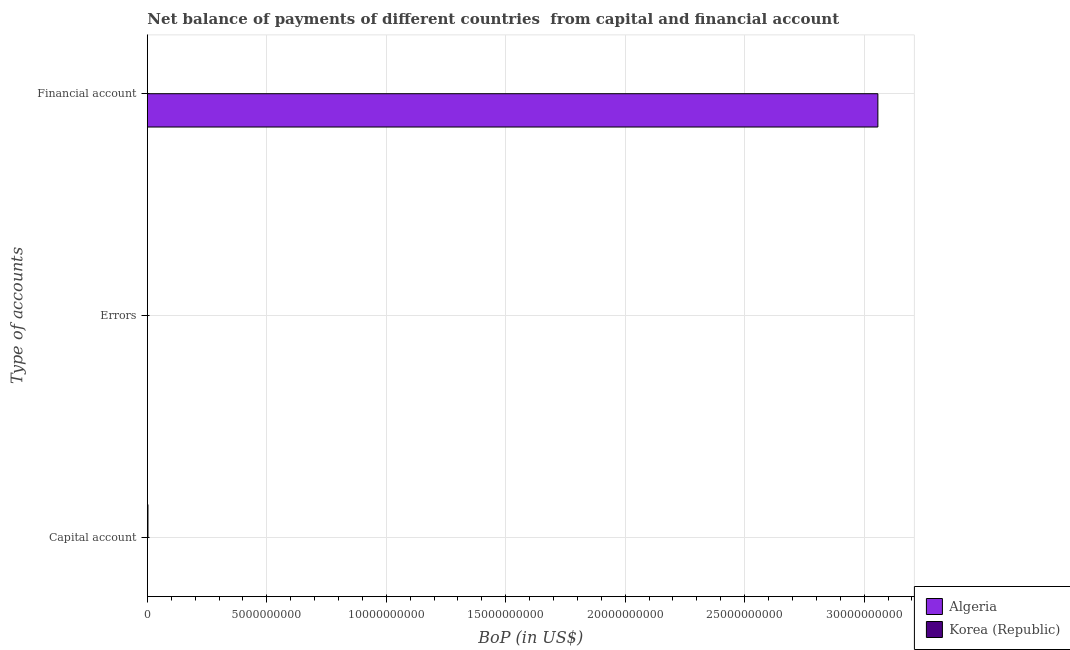Are the number of bars on each tick of the Y-axis equal?
Your answer should be compact. No. How many bars are there on the 3rd tick from the bottom?
Your response must be concise. 1. What is the label of the 1st group of bars from the top?
Give a very brief answer. Financial account. What is the amount of net capital account in Korea (Republic)?
Offer a terse response. 2.64e+07. Across all countries, what is the maximum amount of net capital account?
Keep it short and to the point. 2.64e+07. Across all countries, what is the minimum amount of errors?
Your response must be concise. 0. In which country was the amount of financial account maximum?
Provide a short and direct response. Algeria. What is the total amount of net capital account in the graph?
Ensure brevity in your answer.  2.64e+07. What is the difference between the amount of errors in Algeria and the amount of net capital account in Korea (Republic)?
Your response must be concise. -2.64e+07. What is the average amount of financial account per country?
Offer a very short reply. 1.53e+1. In how many countries, is the amount of net capital account greater than 29000000000 US$?
Give a very brief answer. 0. What is the difference between the highest and the lowest amount of financial account?
Keep it short and to the point. 3.06e+1. In how many countries, is the amount of net capital account greater than the average amount of net capital account taken over all countries?
Your answer should be compact. 1. Is it the case that in every country, the sum of the amount of net capital account and amount of errors is greater than the amount of financial account?
Your answer should be very brief. No. How many bars are there?
Provide a succinct answer. 2. How many countries are there in the graph?
Provide a succinct answer. 2. Where does the legend appear in the graph?
Your answer should be compact. Bottom right. How many legend labels are there?
Provide a succinct answer. 2. How are the legend labels stacked?
Offer a terse response. Vertical. What is the title of the graph?
Your answer should be compact. Net balance of payments of different countries  from capital and financial account. Does "Caribbean small states" appear as one of the legend labels in the graph?
Provide a succinct answer. No. What is the label or title of the X-axis?
Provide a short and direct response. BoP (in US$). What is the label or title of the Y-axis?
Offer a terse response. Type of accounts. What is the BoP (in US$) of Korea (Republic) in Capital account?
Provide a short and direct response. 2.64e+07. What is the BoP (in US$) in Korea (Republic) in Errors?
Offer a very short reply. 0. What is the BoP (in US$) of Algeria in Financial account?
Your answer should be compact. 3.06e+1. Across all Type of accounts, what is the maximum BoP (in US$) in Algeria?
Keep it short and to the point. 3.06e+1. Across all Type of accounts, what is the maximum BoP (in US$) of Korea (Republic)?
Your answer should be very brief. 2.64e+07. Across all Type of accounts, what is the minimum BoP (in US$) of Algeria?
Provide a short and direct response. 0. Across all Type of accounts, what is the minimum BoP (in US$) of Korea (Republic)?
Keep it short and to the point. 0. What is the total BoP (in US$) of Algeria in the graph?
Offer a very short reply. 3.06e+1. What is the total BoP (in US$) of Korea (Republic) in the graph?
Keep it short and to the point. 2.64e+07. What is the average BoP (in US$) in Algeria per Type of accounts?
Give a very brief answer. 1.02e+1. What is the average BoP (in US$) of Korea (Republic) per Type of accounts?
Offer a very short reply. 8.80e+06. What is the difference between the highest and the lowest BoP (in US$) of Algeria?
Your response must be concise. 3.06e+1. What is the difference between the highest and the lowest BoP (in US$) of Korea (Republic)?
Offer a terse response. 2.64e+07. 